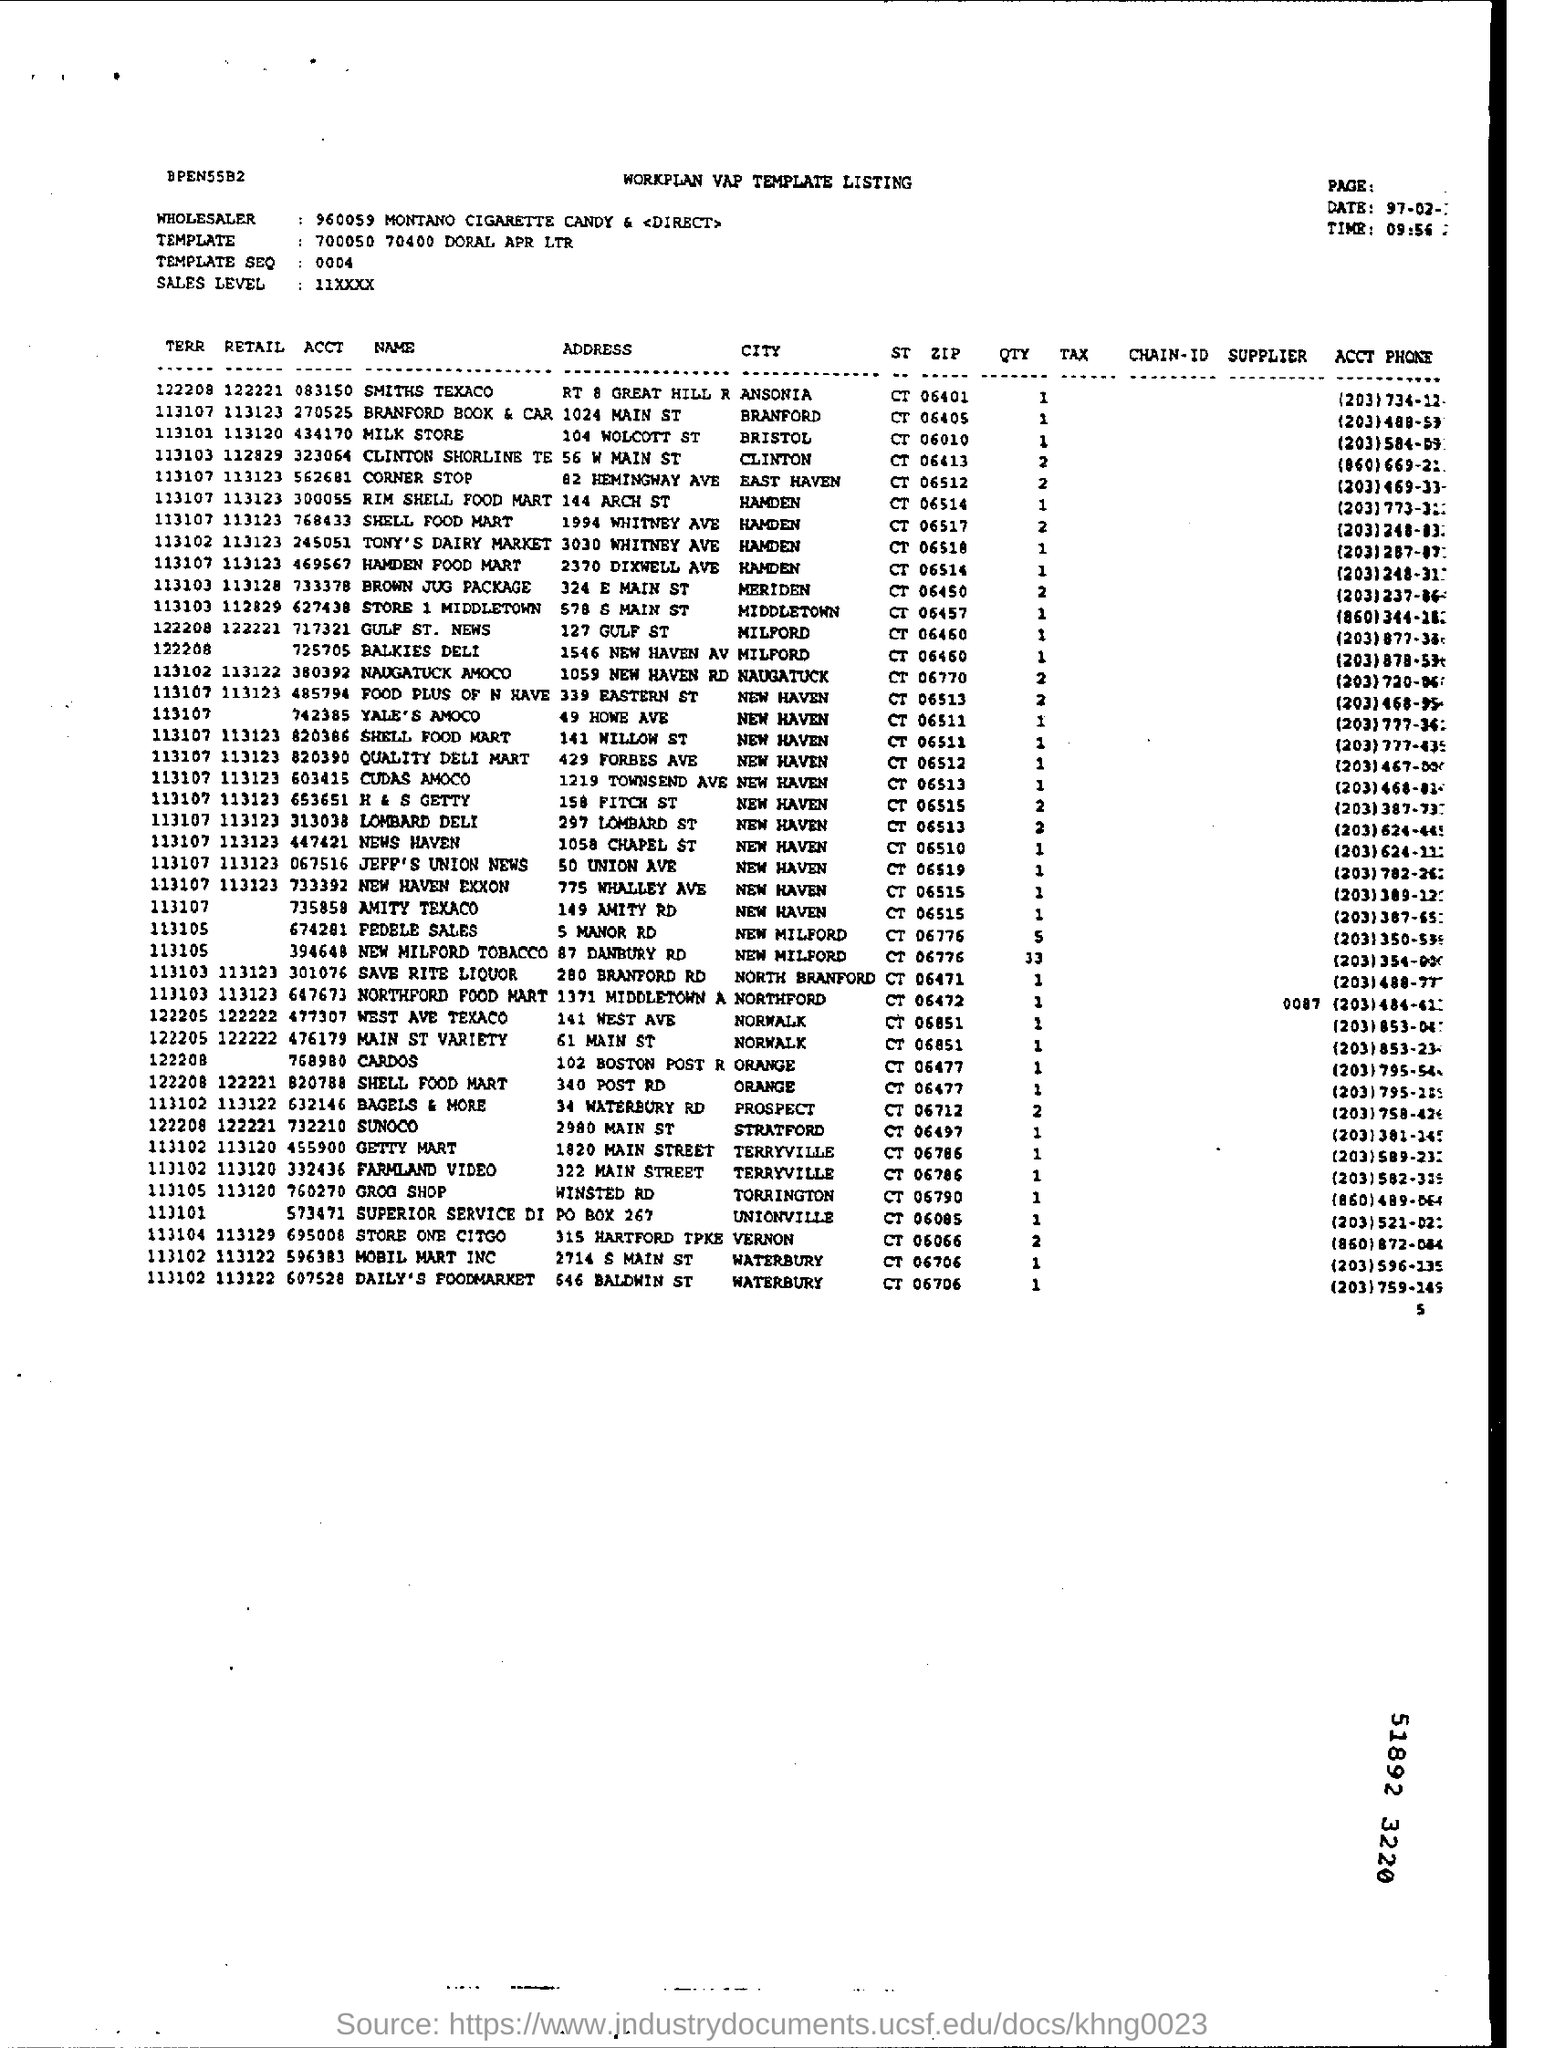What is the name of the wholesaler?
Provide a succinct answer. 960059 MONTANO CIGARETTE CANDY & <DIRECT>. What is the template ?
Provide a short and direct response. 700050 70400 DORAL APR LTR. What is the sales  level mentioned as ?
Make the answer very short. 11xxxx. What is the date mentioned ?
Give a very brief answer. 97-02-:. What is the time mentioned ?
Make the answer very short. 09:56. What is the address of smiths texaco ?
Give a very brief answer. RT 8 GREAT HILL R. 